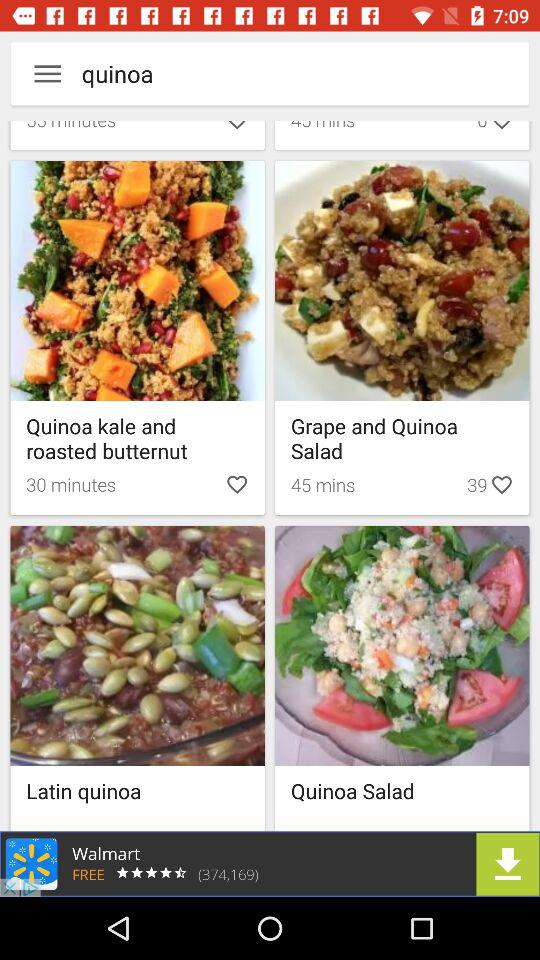How much time is required to prepare "Grape and Quinoa Salad"? The time required to prepare "Grape and Quinoa Salad" is 45 minutes. 